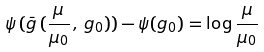<formula> <loc_0><loc_0><loc_500><loc_500>\psi \, ( \bar { g } \, ( \frac { \mu } { \mu _ { 0 } } \, , \, g _ { 0 } ) ) - \psi ( g _ { 0 } ) = \log \frac { \mu } { \mu _ { 0 } }</formula> 